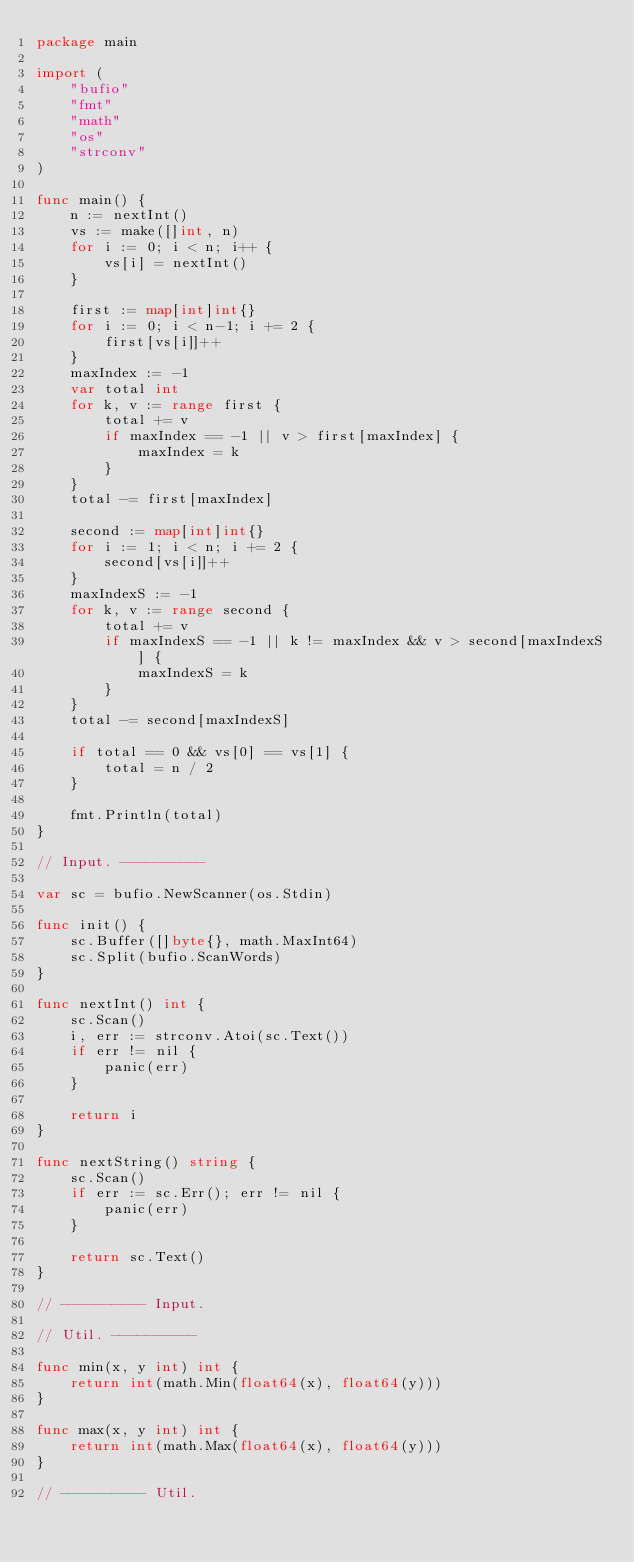Convert code to text. <code><loc_0><loc_0><loc_500><loc_500><_Go_>package main

import (
	"bufio"
	"fmt"
	"math"
	"os"
	"strconv"
)

func main() {
	n := nextInt()
	vs := make([]int, n)
	for i := 0; i < n; i++ {
		vs[i] = nextInt()
	}

	first := map[int]int{}
	for i := 0; i < n-1; i += 2 {
		first[vs[i]]++
	}
	maxIndex := -1
	var total int
	for k, v := range first {
		total += v
		if maxIndex == -1 || v > first[maxIndex] {
			maxIndex = k
		}
	}
	total -= first[maxIndex]

	second := map[int]int{}
	for i := 1; i < n; i += 2 {
		second[vs[i]]++
	}
	maxIndexS := -1
	for k, v := range second {
		total += v
		if maxIndexS == -1 || k != maxIndex && v > second[maxIndexS] {
			maxIndexS = k
		}
	}
	total -= second[maxIndexS]

	if total == 0 && vs[0] == vs[1] {
		total = n / 2
	}

	fmt.Println(total)
}

// Input. ----------

var sc = bufio.NewScanner(os.Stdin)

func init() {
	sc.Buffer([]byte{}, math.MaxInt64)
	sc.Split(bufio.ScanWords)
}

func nextInt() int {
	sc.Scan()
	i, err := strconv.Atoi(sc.Text())
	if err != nil {
		panic(err)
	}

	return i
}

func nextString() string {
	sc.Scan()
	if err := sc.Err(); err != nil {
		panic(err)
	}

	return sc.Text()
}

// ---------- Input.

// Util. ----------

func min(x, y int) int {
	return int(math.Min(float64(x), float64(y)))
}

func max(x, y int) int {
	return int(math.Max(float64(x), float64(y)))
}

// ---------- Util.
</code> 